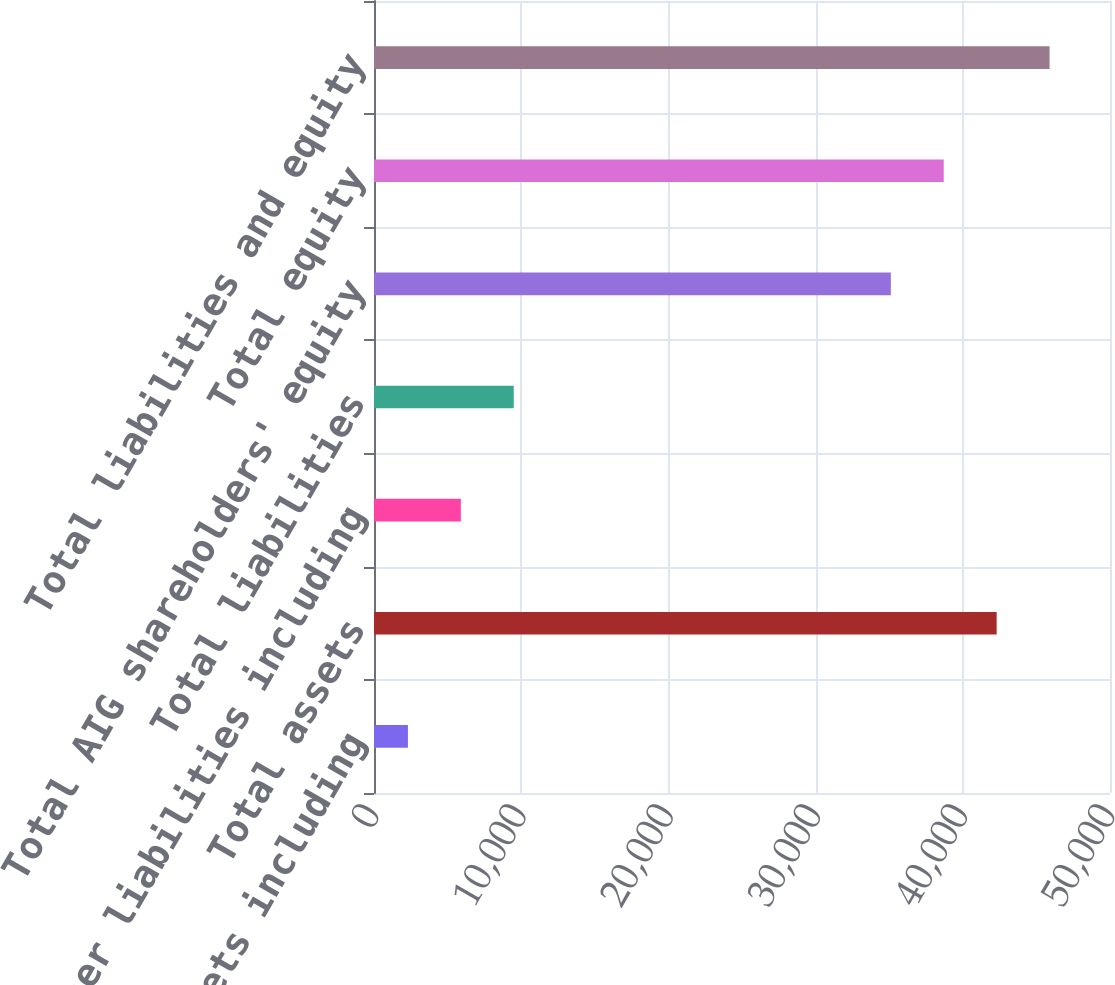<chart> <loc_0><loc_0><loc_500><loc_500><bar_chart><fcel>Other assets including<fcel>Total assets<fcel>Other liabilities including<fcel>Total liabilities<fcel>Total AIG shareholders' equity<fcel>Total equity<fcel>Total liabilities and equity<nl><fcel>2305<fcel>42300.2<fcel>5899.1<fcel>9493.2<fcel>35112<fcel>38706.1<fcel>45894.3<nl></chart> 